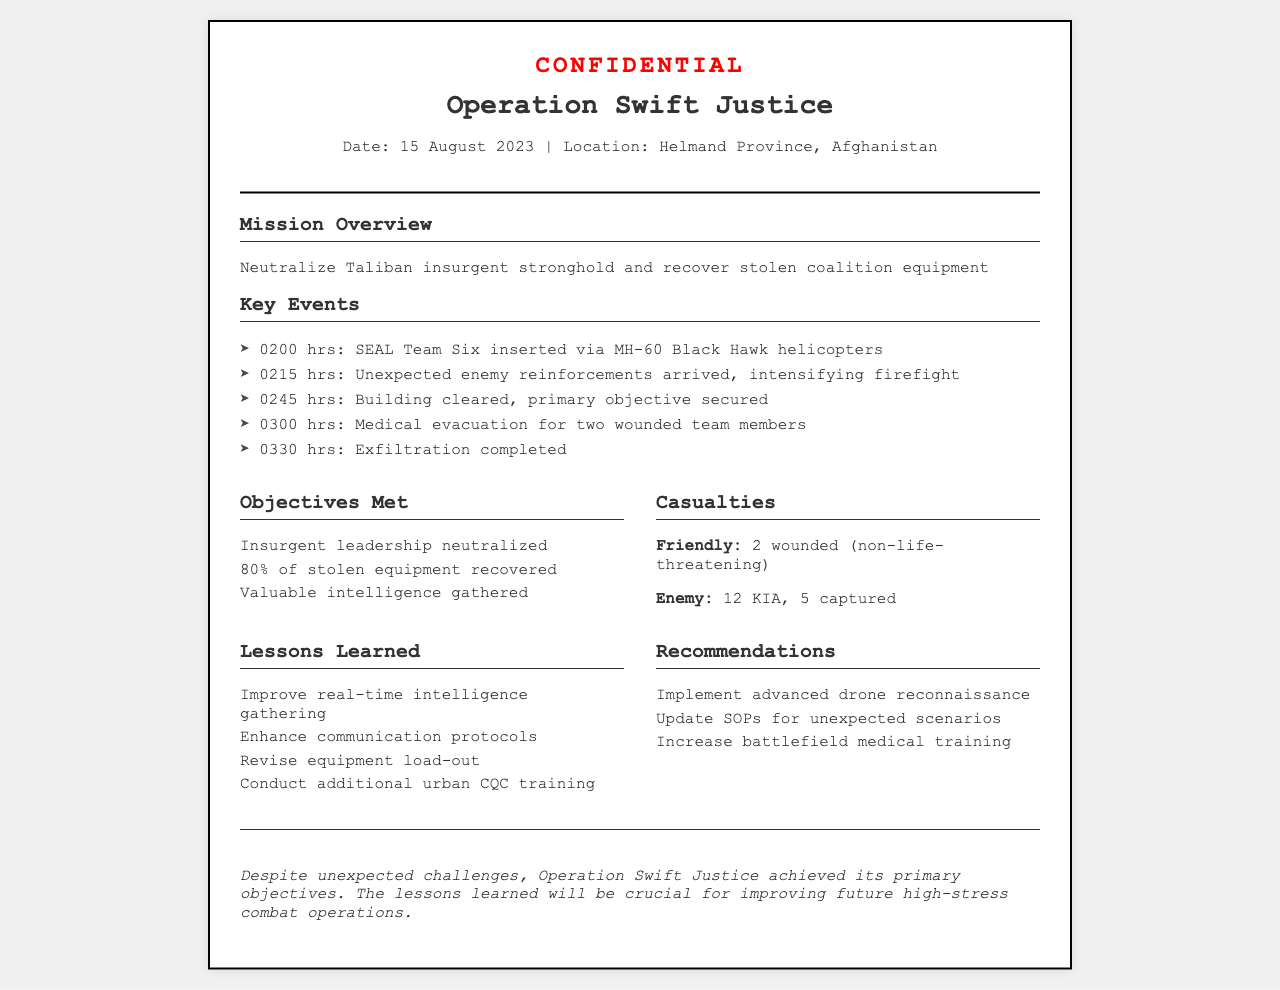what was the date of Operation Swift Justice? The date is mentioned in the header of the document, which is 15 August 2023.
Answer: 15 August 2023 where did the operation take place? The location is specified in the header of the document as Helmand Province, Afghanistan.
Answer: Helmand Province, Afghanistan how many SEAL Team Six members were wounded? The document states that 2 team members were wounded during the operation.
Answer: 2 what percentage of stolen equipment was recovered? The document indicates that 80% of the stolen equipment was recovered.
Answer: 80% what is one lesson learned from the operation? The lessons learned are listed in a section, one of which is to improve real-time intelligence gathering.
Answer: Improve real-time intelligence gathering what was a key event at 0215 hrs? According to the timeline of key events, unexpected enemy reinforcements arrived, intensifying the firefight at 0215 hrs.
Answer: Unexpected enemy reinforcements arrived how many enemy combatants were killed? The casualties section states that 12 enemy combatants were killed in action (KIA).
Answer: 12 KIA what is a recommendation made following the operation? The recommendations section mentions implementing advanced drone reconnaissance as one of the suggestions.
Answer: Implement advanced drone reconnaissance what was the outcome of securing the primary objective? The outcomes section clearly states that the insurgent leadership was neutralized as a result of securing the primary objective.
Answer: Insurgent leadership neutralized 